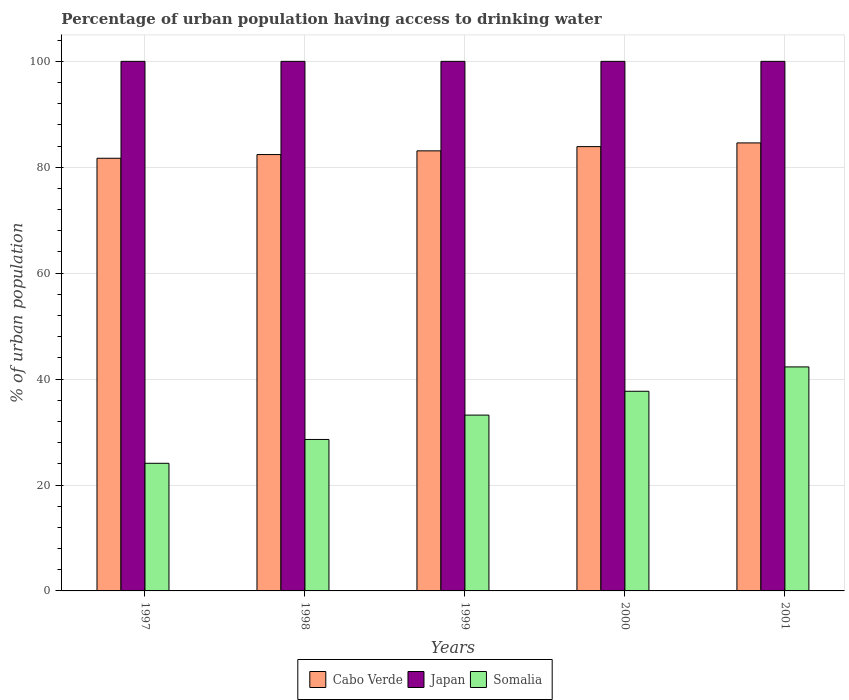How many groups of bars are there?
Provide a short and direct response. 5. How many bars are there on the 4th tick from the right?
Give a very brief answer. 3. What is the label of the 2nd group of bars from the left?
Offer a very short reply. 1998. What is the percentage of urban population having access to drinking water in Japan in 1997?
Ensure brevity in your answer.  100. Across all years, what is the maximum percentage of urban population having access to drinking water in Cabo Verde?
Keep it short and to the point. 84.6. Across all years, what is the minimum percentage of urban population having access to drinking water in Somalia?
Provide a succinct answer. 24.1. In which year was the percentage of urban population having access to drinking water in Cabo Verde minimum?
Make the answer very short. 1997. What is the total percentage of urban population having access to drinking water in Somalia in the graph?
Provide a succinct answer. 165.9. What is the difference between the percentage of urban population having access to drinking water in Cabo Verde in 1998 and that in 2001?
Offer a very short reply. -2.2. What is the difference between the percentage of urban population having access to drinking water in Cabo Verde in 1998 and the percentage of urban population having access to drinking water in Somalia in 1999?
Your answer should be compact. 49.2. What is the average percentage of urban population having access to drinking water in Japan per year?
Provide a succinct answer. 100. In the year 1999, what is the difference between the percentage of urban population having access to drinking water in Japan and percentage of urban population having access to drinking water in Somalia?
Your response must be concise. 66.8. In how many years, is the percentage of urban population having access to drinking water in Japan greater than 80 %?
Your response must be concise. 5. Is the percentage of urban population having access to drinking water in Japan in 1999 less than that in 2001?
Keep it short and to the point. No. Is the difference between the percentage of urban population having access to drinking water in Japan in 2000 and 2001 greater than the difference between the percentage of urban population having access to drinking water in Somalia in 2000 and 2001?
Make the answer very short. Yes. What is the difference between the highest and the second highest percentage of urban population having access to drinking water in Somalia?
Provide a short and direct response. 4.6. In how many years, is the percentage of urban population having access to drinking water in Japan greater than the average percentage of urban population having access to drinking water in Japan taken over all years?
Offer a terse response. 0. Is the sum of the percentage of urban population having access to drinking water in Japan in 1997 and 2000 greater than the maximum percentage of urban population having access to drinking water in Somalia across all years?
Your answer should be compact. Yes. What does the 1st bar from the left in 2000 represents?
Make the answer very short. Cabo Verde. What does the 2nd bar from the right in 2001 represents?
Offer a terse response. Japan. Is it the case that in every year, the sum of the percentage of urban population having access to drinking water in Japan and percentage of urban population having access to drinking water in Cabo Verde is greater than the percentage of urban population having access to drinking water in Somalia?
Your response must be concise. Yes. How many bars are there?
Provide a succinct answer. 15. Are all the bars in the graph horizontal?
Provide a succinct answer. No. How many years are there in the graph?
Offer a very short reply. 5. What is the difference between two consecutive major ticks on the Y-axis?
Offer a terse response. 20. What is the title of the graph?
Your answer should be compact. Percentage of urban population having access to drinking water. Does "Latin America(all income levels)" appear as one of the legend labels in the graph?
Ensure brevity in your answer.  No. What is the label or title of the X-axis?
Your answer should be very brief. Years. What is the label or title of the Y-axis?
Your answer should be compact. % of urban population. What is the % of urban population of Cabo Verde in 1997?
Provide a succinct answer. 81.7. What is the % of urban population in Somalia in 1997?
Ensure brevity in your answer.  24.1. What is the % of urban population of Cabo Verde in 1998?
Provide a succinct answer. 82.4. What is the % of urban population in Somalia in 1998?
Give a very brief answer. 28.6. What is the % of urban population of Cabo Verde in 1999?
Keep it short and to the point. 83.1. What is the % of urban population in Somalia in 1999?
Offer a terse response. 33.2. What is the % of urban population of Cabo Verde in 2000?
Keep it short and to the point. 83.9. What is the % of urban population in Somalia in 2000?
Give a very brief answer. 37.7. What is the % of urban population in Cabo Verde in 2001?
Your answer should be very brief. 84.6. What is the % of urban population of Somalia in 2001?
Give a very brief answer. 42.3. Across all years, what is the maximum % of urban population of Cabo Verde?
Ensure brevity in your answer.  84.6. Across all years, what is the maximum % of urban population in Japan?
Provide a succinct answer. 100. Across all years, what is the maximum % of urban population of Somalia?
Offer a terse response. 42.3. Across all years, what is the minimum % of urban population in Cabo Verde?
Ensure brevity in your answer.  81.7. Across all years, what is the minimum % of urban population of Japan?
Give a very brief answer. 100. Across all years, what is the minimum % of urban population in Somalia?
Your answer should be very brief. 24.1. What is the total % of urban population in Cabo Verde in the graph?
Provide a succinct answer. 415.7. What is the total % of urban population of Japan in the graph?
Your answer should be compact. 500. What is the total % of urban population of Somalia in the graph?
Your answer should be very brief. 165.9. What is the difference between the % of urban population in Cabo Verde in 1997 and that in 1998?
Give a very brief answer. -0.7. What is the difference between the % of urban population of Japan in 1997 and that in 1998?
Your answer should be very brief. 0. What is the difference between the % of urban population of Somalia in 1997 and that in 1998?
Your answer should be compact. -4.5. What is the difference between the % of urban population in Cabo Verde in 1997 and that in 1999?
Offer a terse response. -1.4. What is the difference between the % of urban population of Japan in 1997 and that in 1999?
Your answer should be compact. 0. What is the difference between the % of urban population in Somalia in 1997 and that in 1999?
Your answer should be compact. -9.1. What is the difference between the % of urban population in Japan in 1997 and that in 2000?
Your answer should be very brief. 0. What is the difference between the % of urban population of Somalia in 1997 and that in 2000?
Ensure brevity in your answer.  -13.6. What is the difference between the % of urban population in Japan in 1997 and that in 2001?
Your response must be concise. 0. What is the difference between the % of urban population in Somalia in 1997 and that in 2001?
Your response must be concise. -18.2. What is the difference between the % of urban population of Cabo Verde in 1998 and that in 2001?
Your response must be concise. -2.2. What is the difference between the % of urban population of Japan in 1998 and that in 2001?
Offer a terse response. 0. What is the difference between the % of urban population of Somalia in 1998 and that in 2001?
Your response must be concise. -13.7. What is the difference between the % of urban population of Japan in 1999 and that in 2001?
Offer a very short reply. 0. What is the difference between the % of urban population in Somalia in 2000 and that in 2001?
Ensure brevity in your answer.  -4.6. What is the difference between the % of urban population in Cabo Verde in 1997 and the % of urban population in Japan in 1998?
Offer a terse response. -18.3. What is the difference between the % of urban population in Cabo Verde in 1997 and the % of urban population in Somalia in 1998?
Offer a very short reply. 53.1. What is the difference between the % of urban population of Japan in 1997 and the % of urban population of Somalia in 1998?
Your response must be concise. 71.4. What is the difference between the % of urban population in Cabo Verde in 1997 and the % of urban population in Japan in 1999?
Offer a terse response. -18.3. What is the difference between the % of urban population in Cabo Verde in 1997 and the % of urban population in Somalia in 1999?
Give a very brief answer. 48.5. What is the difference between the % of urban population in Japan in 1997 and the % of urban population in Somalia in 1999?
Make the answer very short. 66.8. What is the difference between the % of urban population in Cabo Verde in 1997 and the % of urban population in Japan in 2000?
Give a very brief answer. -18.3. What is the difference between the % of urban population in Cabo Verde in 1997 and the % of urban population in Somalia in 2000?
Offer a very short reply. 44. What is the difference between the % of urban population in Japan in 1997 and the % of urban population in Somalia in 2000?
Your response must be concise. 62.3. What is the difference between the % of urban population of Cabo Verde in 1997 and the % of urban population of Japan in 2001?
Give a very brief answer. -18.3. What is the difference between the % of urban population of Cabo Verde in 1997 and the % of urban population of Somalia in 2001?
Your answer should be compact. 39.4. What is the difference between the % of urban population of Japan in 1997 and the % of urban population of Somalia in 2001?
Make the answer very short. 57.7. What is the difference between the % of urban population in Cabo Verde in 1998 and the % of urban population in Japan in 1999?
Offer a terse response. -17.6. What is the difference between the % of urban population of Cabo Verde in 1998 and the % of urban population of Somalia in 1999?
Your response must be concise. 49.2. What is the difference between the % of urban population of Japan in 1998 and the % of urban population of Somalia in 1999?
Ensure brevity in your answer.  66.8. What is the difference between the % of urban population in Cabo Verde in 1998 and the % of urban population in Japan in 2000?
Keep it short and to the point. -17.6. What is the difference between the % of urban population in Cabo Verde in 1998 and the % of urban population in Somalia in 2000?
Your answer should be very brief. 44.7. What is the difference between the % of urban population in Japan in 1998 and the % of urban population in Somalia in 2000?
Make the answer very short. 62.3. What is the difference between the % of urban population in Cabo Verde in 1998 and the % of urban population in Japan in 2001?
Provide a short and direct response. -17.6. What is the difference between the % of urban population in Cabo Verde in 1998 and the % of urban population in Somalia in 2001?
Make the answer very short. 40.1. What is the difference between the % of urban population in Japan in 1998 and the % of urban population in Somalia in 2001?
Your response must be concise. 57.7. What is the difference between the % of urban population of Cabo Verde in 1999 and the % of urban population of Japan in 2000?
Your response must be concise. -16.9. What is the difference between the % of urban population of Cabo Verde in 1999 and the % of urban population of Somalia in 2000?
Make the answer very short. 45.4. What is the difference between the % of urban population in Japan in 1999 and the % of urban population in Somalia in 2000?
Make the answer very short. 62.3. What is the difference between the % of urban population in Cabo Verde in 1999 and the % of urban population in Japan in 2001?
Provide a succinct answer. -16.9. What is the difference between the % of urban population of Cabo Verde in 1999 and the % of urban population of Somalia in 2001?
Keep it short and to the point. 40.8. What is the difference between the % of urban population in Japan in 1999 and the % of urban population in Somalia in 2001?
Provide a succinct answer. 57.7. What is the difference between the % of urban population in Cabo Verde in 2000 and the % of urban population in Japan in 2001?
Give a very brief answer. -16.1. What is the difference between the % of urban population in Cabo Verde in 2000 and the % of urban population in Somalia in 2001?
Make the answer very short. 41.6. What is the difference between the % of urban population in Japan in 2000 and the % of urban population in Somalia in 2001?
Ensure brevity in your answer.  57.7. What is the average % of urban population in Cabo Verde per year?
Make the answer very short. 83.14. What is the average % of urban population in Somalia per year?
Give a very brief answer. 33.18. In the year 1997, what is the difference between the % of urban population of Cabo Verde and % of urban population of Japan?
Your response must be concise. -18.3. In the year 1997, what is the difference between the % of urban population in Cabo Verde and % of urban population in Somalia?
Your response must be concise. 57.6. In the year 1997, what is the difference between the % of urban population in Japan and % of urban population in Somalia?
Provide a succinct answer. 75.9. In the year 1998, what is the difference between the % of urban population of Cabo Verde and % of urban population of Japan?
Give a very brief answer. -17.6. In the year 1998, what is the difference between the % of urban population of Cabo Verde and % of urban population of Somalia?
Give a very brief answer. 53.8. In the year 1998, what is the difference between the % of urban population in Japan and % of urban population in Somalia?
Make the answer very short. 71.4. In the year 1999, what is the difference between the % of urban population in Cabo Verde and % of urban population in Japan?
Your answer should be compact. -16.9. In the year 1999, what is the difference between the % of urban population of Cabo Verde and % of urban population of Somalia?
Provide a short and direct response. 49.9. In the year 1999, what is the difference between the % of urban population of Japan and % of urban population of Somalia?
Your answer should be compact. 66.8. In the year 2000, what is the difference between the % of urban population of Cabo Verde and % of urban population of Japan?
Ensure brevity in your answer.  -16.1. In the year 2000, what is the difference between the % of urban population of Cabo Verde and % of urban population of Somalia?
Provide a succinct answer. 46.2. In the year 2000, what is the difference between the % of urban population in Japan and % of urban population in Somalia?
Your answer should be very brief. 62.3. In the year 2001, what is the difference between the % of urban population in Cabo Verde and % of urban population in Japan?
Offer a terse response. -15.4. In the year 2001, what is the difference between the % of urban population of Cabo Verde and % of urban population of Somalia?
Provide a short and direct response. 42.3. In the year 2001, what is the difference between the % of urban population in Japan and % of urban population in Somalia?
Keep it short and to the point. 57.7. What is the ratio of the % of urban population in Japan in 1997 to that in 1998?
Provide a succinct answer. 1. What is the ratio of the % of urban population in Somalia in 1997 to that in 1998?
Ensure brevity in your answer.  0.84. What is the ratio of the % of urban population of Cabo Verde in 1997 to that in 1999?
Offer a terse response. 0.98. What is the ratio of the % of urban population in Japan in 1997 to that in 1999?
Your answer should be compact. 1. What is the ratio of the % of urban population in Somalia in 1997 to that in 1999?
Ensure brevity in your answer.  0.73. What is the ratio of the % of urban population of Cabo Verde in 1997 to that in 2000?
Give a very brief answer. 0.97. What is the ratio of the % of urban population in Somalia in 1997 to that in 2000?
Keep it short and to the point. 0.64. What is the ratio of the % of urban population in Cabo Verde in 1997 to that in 2001?
Your answer should be compact. 0.97. What is the ratio of the % of urban population in Somalia in 1997 to that in 2001?
Provide a succinct answer. 0.57. What is the ratio of the % of urban population of Cabo Verde in 1998 to that in 1999?
Offer a very short reply. 0.99. What is the ratio of the % of urban population of Japan in 1998 to that in 1999?
Offer a very short reply. 1. What is the ratio of the % of urban population of Somalia in 1998 to that in 1999?
Provide a succinct answer. 0.86. What is the ratio of the % of urban population in Cabo Verde in 1998 to that in 2000?
Ensure brevity in your answer.  0.98. What is the ratio of the % of urban population of Japan in 1998 to that in 2000?
Provide a succinct answer. 1. What is the ratio of the % of urban population of Somalia in 1998 to that in 2000?
Make the answer very short. 0.76. What is the ratio of the % of urban population of Cabo Verde in 1998 to that in 2001?
Your response must be concise. 0.97. What is the ratio of the % of urban population in Somalia in 1998 to that in 2001?
Your answer should be compact. 0.68. What is the ratio of the % of urban population of Japan in 1999 to that in 2000?
Provide a succinct answer. 1. What is the ratio of the % of urban population in Somalia in 1999 to that in 2000?
Your answer should be very brief. 0.88. What is the ratio of the % of urban population of Cabo Verde in 1999 to that in 2001?
Your response must be concise. 0.98. What is the ratio of the % of urban population in Japan in 1999 to that in 2001?
Your answer should be very brief. 1. What is the ratio of the % of urban population in Somalia in 1999 to that in 2001?
Your response must be concise. 0.78. What is the ratio of the % of urban population in Cabo Verde in 2000 to that in 2001?
Offer a terse response. 0.99. What is the ratio of the % of urban population of Japan in 2000 to that in 2001?
Make the answer very short. 1. What is the ratio of the % of urban population of Somalia in 2000 to that in 2001?
Provide a succinct answer. 0.89. What is the difference between the highest and the lowest % of urban population of Cabo Verde?
Give a very brief answer. 2.9. What is the difference between the highest and the lowest % of urban population of Japan?
Offer a terse response. 0. 